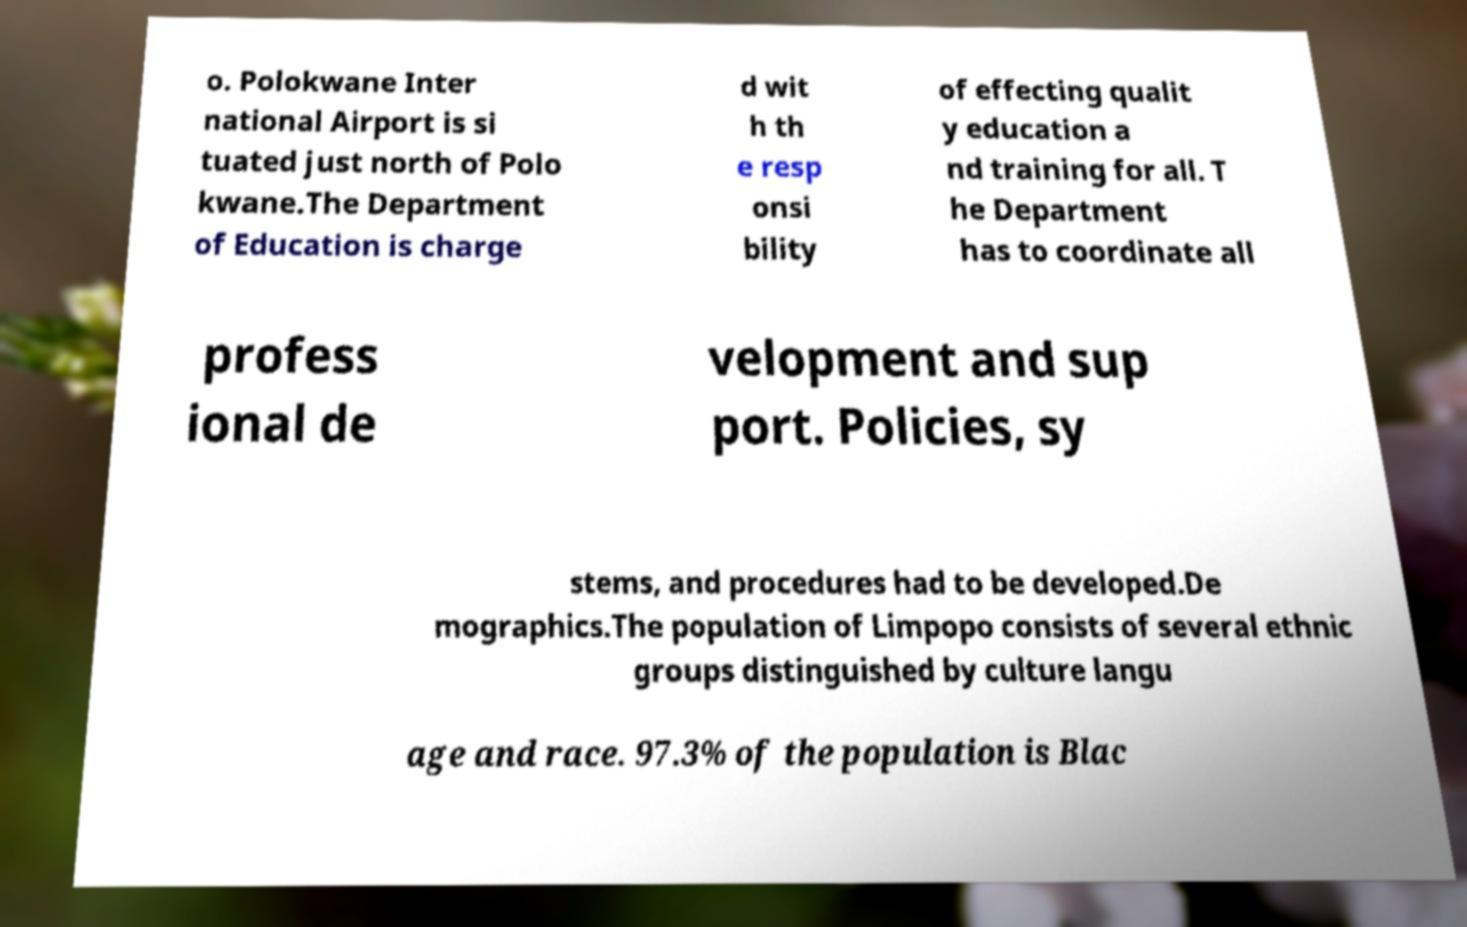What messages or text are displayed in this image? I need them in a readable, typed format. o. Polokwane Inter national Airport is si tuated just north of Polo kwane.The Department of Education is charge d wit h th e resp onsi bility of effecting qualit y education a nd training for all. T he Department has to coordinate all profess ional de velopment and sup port. Policies, sy stems, and procedures had to be developed.De mographics.The population of Limpopo consists of several ethnic groups distinguished by culture langu age and race. 97.3% of the population is Blac 